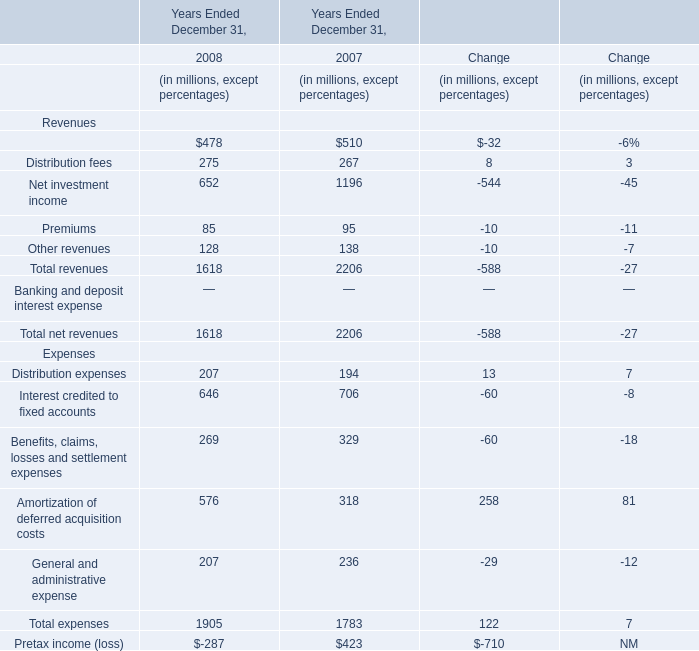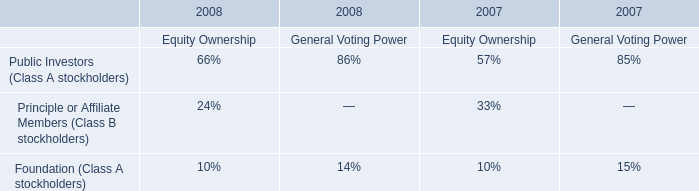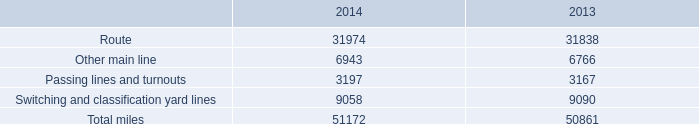What is the difference between the greatest revenues in 2008 and 2007？ (in millions) 
Computations: (478 - 510)
Answer: -32.0. What's the total amount of revenues excluding those negative ones in 2008? (in millions) 
Computations: ((((478 + 275) + 652) + 85) + 128)
Answer: 1618.0. what is the average number of total track miles per state in the rail network ? 
Computations: (51172 / 23)
Answer: 2224.86957. 